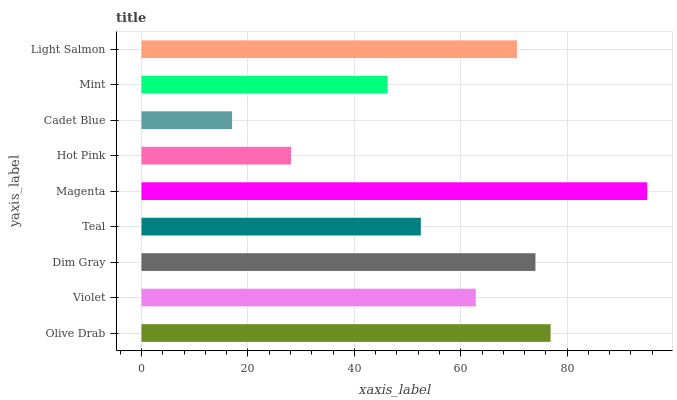Is Cadet Blue the minimum?
Answer yes or no. Yes. Is Magenta the maximum?
Answer yes or no. Yes. Is Violet the minimum?
Answer yes or no. No. Is Violet the maximum?
Answer yes or no. No. Is Olive Drab greater than Violet?
Answer yes or no. Yes. Is Violet less than Olive Drab?
Answer yes or no. Yes. Is Violet greater than Olive Drab?
Answer yes or no. No. Is Olive Drab less than Violet?
Answer yes or no. No. Is Violet the high median?
Answer yes or no. Yes. Is Violet the low median?
Answer yes or no. Yes. Is Mint the high median?
Answer yes or no. No. Is Olive Drab the low median?
Answer yes or no. No. 